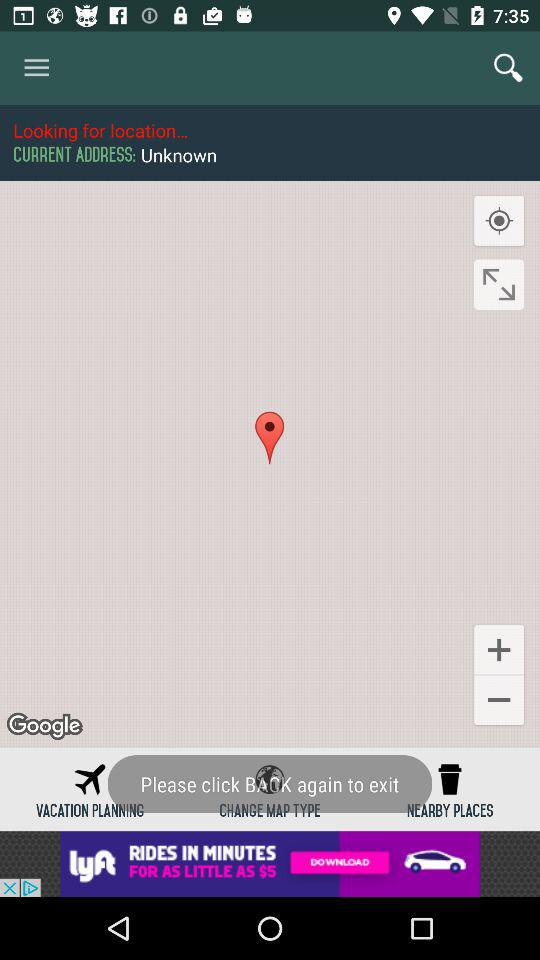What is the current address? The current address is "Unknown". 